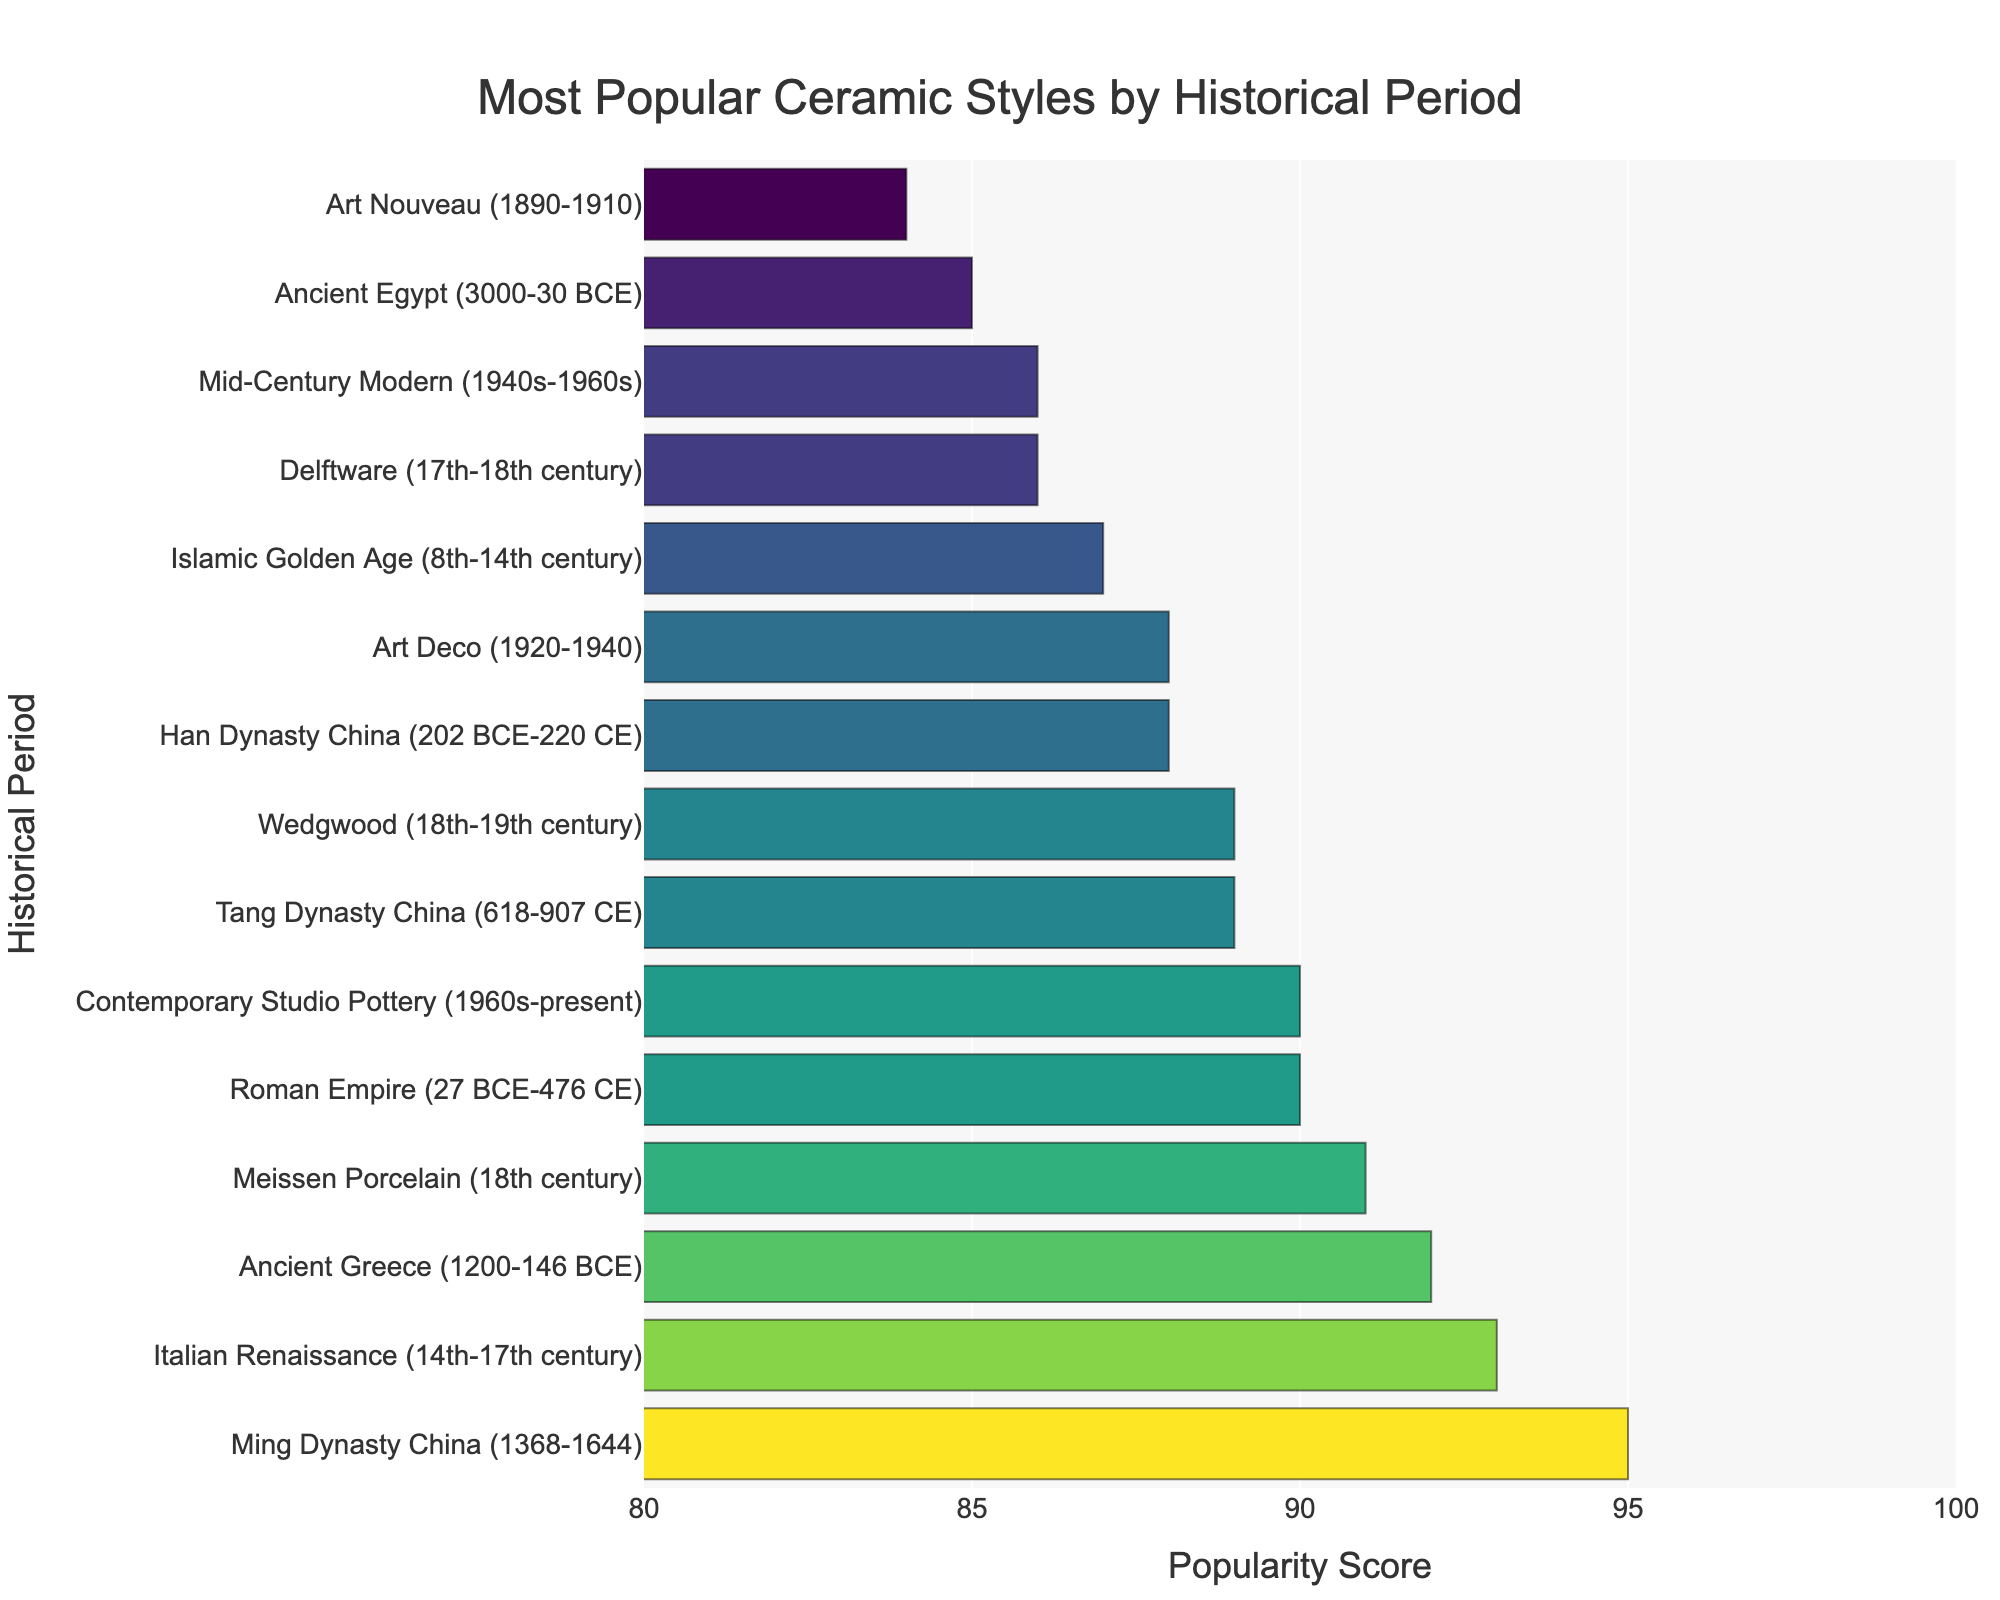Which period has the highest popularity score? The bar representing the Ming Dynasty China period reaches the highest point on the x-axis with a score of 95.
Answer: Ming Dynasty China Which periods have popularity scores greater than 90? The bars for Ancient Greece, Roman Empire, Italian Renaissance, Ming Dynasty China, and Meissen Porcelain all exceed a popularity score of 90.
Answer: Ancient Greece, Roman Empire, Italian Renaissance, Ming Dynasty China, Meissen Porcelain What is the difference in popularity scores between the Han Dynasty China and Art Nouveau? The popularity score for Han Dynasty China is 88, while Art Nouveau is 84. The difference between them is 88 - 84 = 4.
Answer: 4 Between "Art Deco" and "Islamic Golden Age," which period has a higher popularity score and by how much? Art Deco has a popularity score of 88 and Islamic Golden Age has a score of 87, so Art Deco is higher by 88 - 87 = 1.
Answer: Art Deco by 1 What is the average popularity score of the periods from the 18th century? The periods from the 18th century are Meissen Porcelain with a score of 91 and Wedgwood with a score of 89. The average is (91 + 89) / 2 = 90.
Answer: 90 What is the range of the popularity scores in the chart? The highest popularity score is 95 (Ming Dynasty China), and the lowest is 84 (Art Nouveau), so the range is 95 - 84 = 11.
Answer: 11 Which period shows its bar in a darker color, indicating a higher popularity score, when comparing the Italian Renaissance and Contemporary Studio Pottery? Both Italian Renaissance and Contemporary Studio Pottery have similarly high popularity scores, but the Italian Renaissance has a score of 93 and Contemporary Studio Pottery has 90. Hence, the Italian Renaissance has a darker bar color indicating a higher score.
Answer: Italian Renaissance How many periods have popularity scores between 85 and 90, inclusive? The periods with popularity scores between 85 and 90 are Ancient Egypt (85), Han Dynasty China (88), Tang Dynasty China (89), Islamic Golden Age (87), Delftware (86), Art Deco (88), and Mid-Century Modern (86). That sums up to 7 periods.
Answer: 7 What is the sum of the popularity scores of the periods from Ancient Egypt to Roman Empire (chronologically)? The popularity scores are: Ancient Egypt (85), Ancient Greece (92), Han Dynasty China (88), and Roman Empire (90). The sum is 85 + 92 + 88 + 90 = 355.
Answer: 355 Are any periods tied in their popularity scores? If so, which ones? The periods Tang Dynasty China and Wedgwood both have a popularity score of 89.
Answer: Tang Dynasty China, Wedgwood 